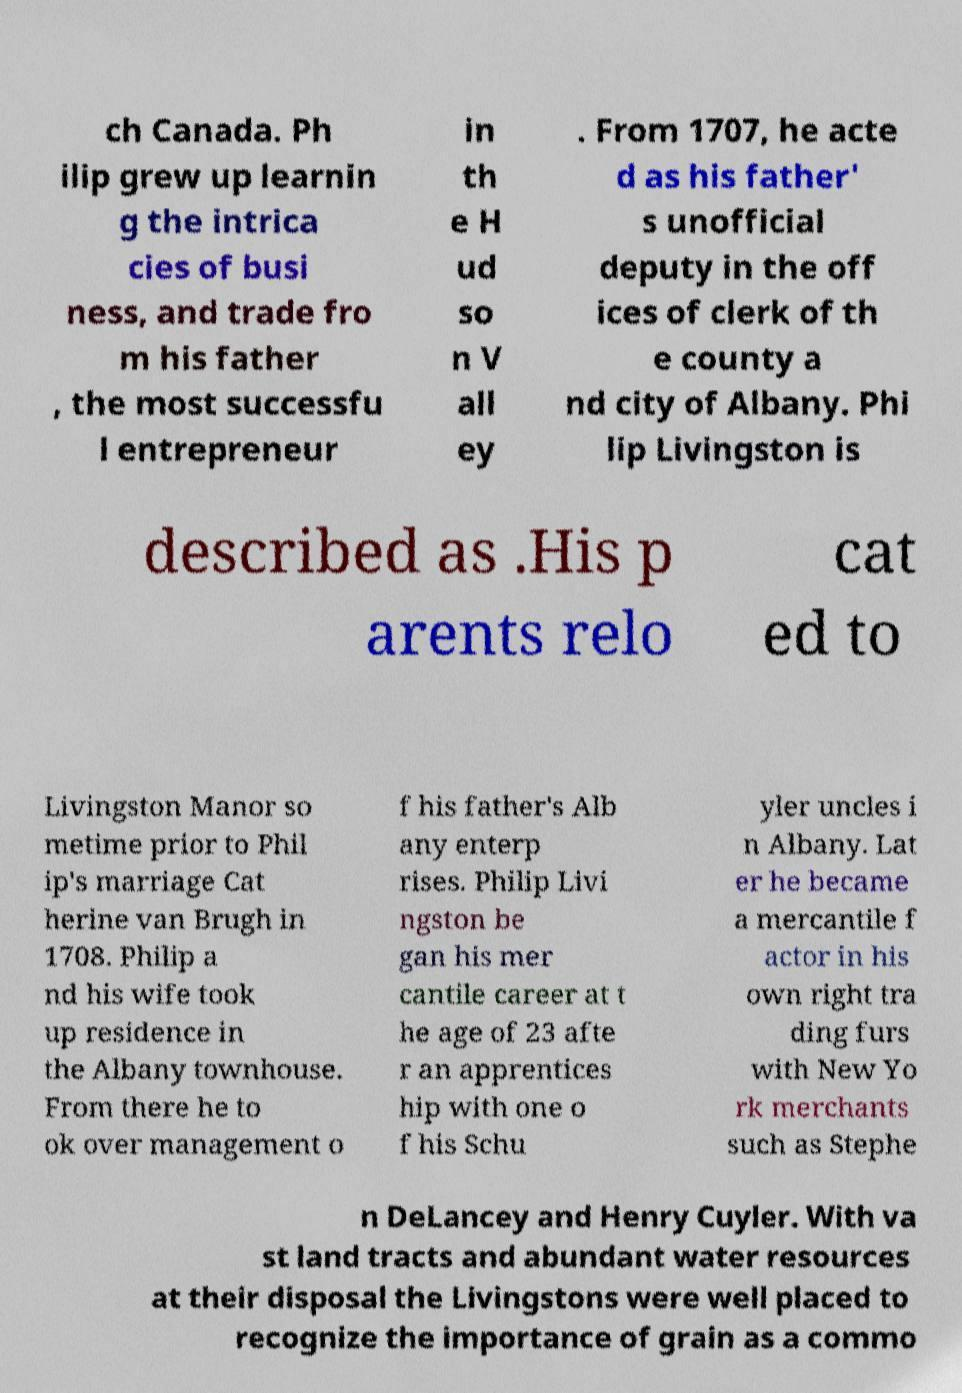Please identify and transcribe the text found in this image. ch Canada. Ph ilip grew up learnin g the intrica cies of busi ness, and trade fro m his father , the most successfu l entrepreneur in th e H ud so n V all ey . From 1707, he acte d as his father' s unofficial deputy in the off ices of clerk of th e county a nd city of Albany. Phi lip Livingston is described as .His p arents relo cat ed to Livingston Manor so metime prior to Phil ip's marriage Cat herine van Brugh in 1708. Philip a nd his wife took up residence in the Albany townhouse. From there he to ok over management o f his father's Alb any enterp rises. Philip Livi ngston be gan his mer cantile career at t he age of 23 afte r an apprentices hip with one o f his Schu yler uncles i n Albany. Lat er he became a mercantile f actor in his own right tra ding furs with New Yo rk merchants such as Stephe n DeLancey and Henry Cuyler. With va st land tracts and abundant water resources at their disposal the Livingstons were well placed to recognize the importance of grain as a commo 